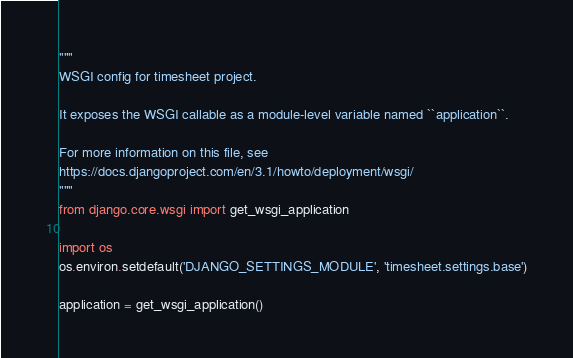Convert code to text. <code><loc_0><loc_0><loc_500><loc_500><_Python_>"""
WSGI config for timesheet project.

It exposes the WSGI callable as a module-level variable named ``application``.

For more information on this file, see
https://docs.djangoproject.com/en/3.1/howto/deployment/wsgi/
"""
from django.core.wsgi import get_wsgi_application

import os
os.environ.setdefault('DJANGO_SETTINGS_MODULE', 'timesheet.settings.base')

application = get_wsgi_application()
</code> 